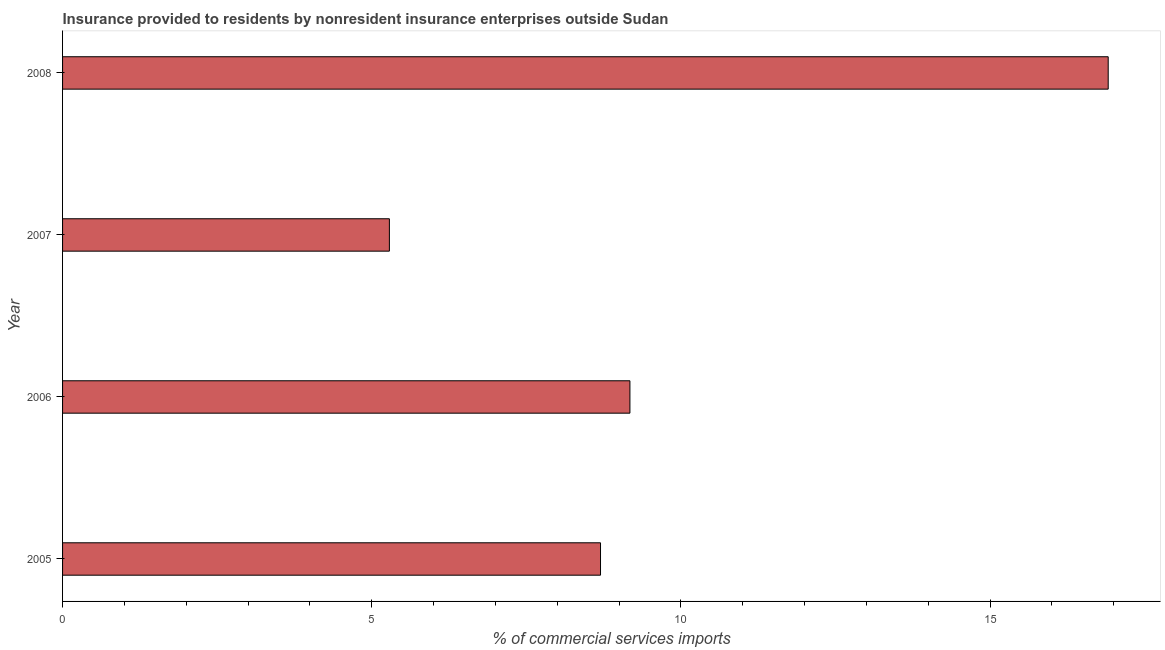Does the graph contain any zero values?
Ensure brevity in your answer.  No. Does the graph contain grids?
Your answer should be very brief. No. What is the title of the graph?
Your answer should be very brief. Insurance provided to residents by nonresident insurance enterprises outside Sudan. What is the label or title of the X-axis?
Your answer should be compact. % of commercial services imports. What is the insurance provided by non-residents in 2006?
Ensure brevity in your answer.  9.17. Across all years, what is the maximum insurance provided by non-residents?
Give a very brief answer. 16.91. Across all years, what is the minimum insurance provided by non-residents?
Your answer should be compact. 5.29. In which year was the insurance provided by non-residents maximum?
Make the answer very short. 2008. In which year was the insurance provided by non-residents minimum?
Give a very brief answer. 2007. What is the sum of the insurance provided by non-residents?
Keep it short and to the point. 40.07. What is the difference between the insurance provided by non-residents in 2005 and 2007?
Your response must be concise. 3.41. What is the average insurance provided by non-residents per year?
Give a very brief answer. 10.02. What is the median insurance provided by non-residents?
Provide a short and direct response. 8.94. In how many years, is the insurance provided by non-residents greater than 4 %?
Provide a succinct answer. 4. Do a majority of the years between 2008 and 2007 (inclusive) have insurance provided by non-residents greater than 5 %?
Ensure brevity in your answer.  No. What is the ratio of the insurance provided by non-residents in 2005 to that in 2007?
Provide a succinct answer. 1.65. Is the difference between the insurance provided by non-residents in 2005 and 2008 greater than the difference between any two years?
Offer a terse response. No. What is the difference between the highest and the second highest insurance provided by non-residents?
Offer a terse response. 7.73. Is the sum of the insurance provided by non-residents in 2005 and 2006 greater than the maximum insurance provided by non-residents across all years?
Your response must be concise. Yes. What is the difference between the highest and the lowest insurance provided by non-residents?
Give a very brief answer. 11.62. In how many years, is the insurance provided by non-residents greater than the average insurance provided by non-residents taken over all years?
Make the answer very short. 1. How many bars are there?
Your answer should be compact. 4. Are all the bars in the graph horizontal?
Your answer should be very brief. Yes. How many years are there in the graph?
Your response must be concise. 4. What is the difference between two consecutive major ticks on the X-axis?
Provide a short and direct response. 5. Are the values on the major ticks of X-axis written in scientific E-notation?
Ensure brevity in your answer.  No. What is the % of commercial services imports in 2005?
Offer a terse response. 8.7. What is the % of commercial services imports in 2006?
Ensure brevity in your answer.  9.17. What is the % of commercial services imports in 2007?
Your response must be concise. 5.29. What is the % of commercial services imports of 2008?
Keep it short and to the point. 16.91. What is the difference between the % of commercial services imports in 2005 and 2006?
Your response must be concise. -0.48. What is the difference between the % of commercial services imports in 2005 and 2007?
Provide a short and direct response. 3.41. What is the difference between the % of commercial services imports in 2005 and 2008?
Your response must be concise. -8.21. What is the difference between the % of commercial services imports in 2006 and 2007?
Ensure brevity in your answer.  3.89. What is the difference between the % of commercial services imports in 2006 and 2008?
Ensure brevity in your answer.  -7.73. What is the difference between the % of commercial services imports in 2007 and 2008?
Give a very brief answer. -11.62. What is the ratio of the % of commercial services imports in 2005 to that in 2006?
Make the answer very short. 0.95. What is the ratio of the % of commercial services imports in 2005 to that in 2007?
Keep it short and to the point. 1.65. What is the ratio of the % of commercial services imports in 2005 to that in 2008?
Offer a very short reply. 0.51. What is the ratio of the % of commercial services imports in 2006 to that in 2007?
Offer a very short reply. 1.74. What is the ratio of the % of commercial services imports in 2006 to that in 2008?
Give a very brief answer. 0.54. What is the ratio of the % of commercial services imports in 2007 to that in 2008?
Ensure brevity in your answer.  0.31. 